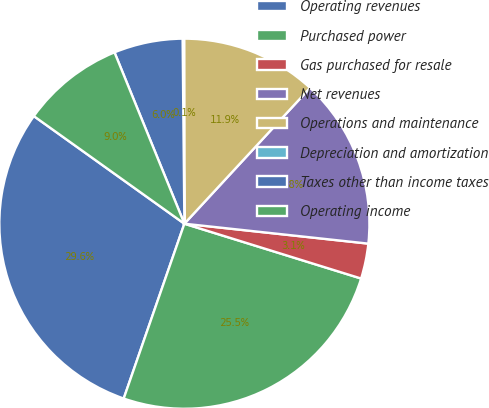<chart> <loc_0><loc_0><loc_500><loc_500><pie_chart><fcel>Operating revenues<fcel>Purchased power<fcel>Gas purchased for resale<fcel>Net revenues<fcel>Operations and maintenance<fcel>Depreciation and amortization<fcel>Taxes other than income taxes<fcel>Operating income<nl><fcel>29.56%<fcel>25.53%<fcel>3.07%<fcel>14.84%<fcel>11.9%<fcel>0.13%<fcel>6.01%<fcel>8.96%<nl></chart> 